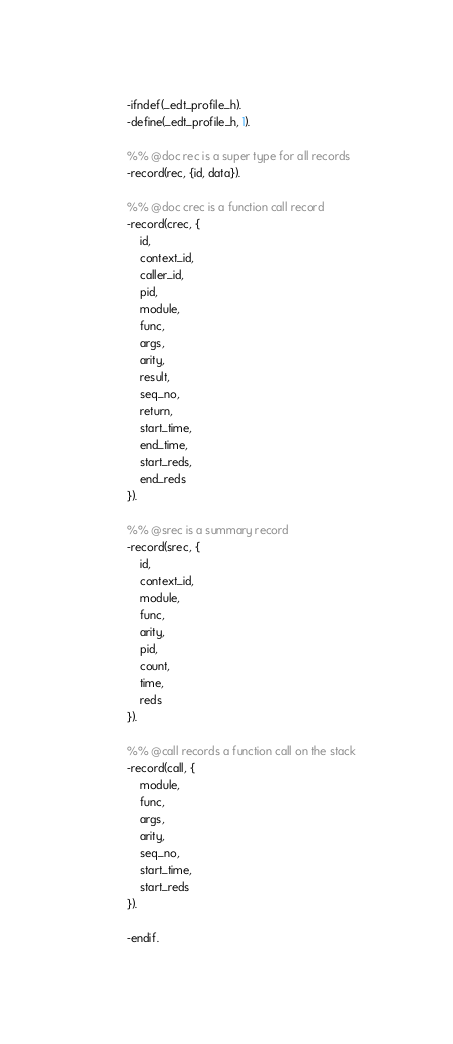<code> <loc_0><loc_0><loc_500><loc_500><_Erlang_>-ifndef(_edt_profile_h).
-define(_edt_profile_h, 1).

%% @doc rec is a super type for all records
-record(rec, {id, data}).

%% @doc crec is a function call record
-record(crec, {
    id,
    context_id,
    caller_id,
    pid,
    module,
    func,
    args,
    arity,
    result,
    seq_no,
    return,
    start_time,
    end_time,
    start_reds,
    end_reds
}).

%% @srec is a summary record
-record(srec, {
    id,
    context_id,
    module,
    func,
    arity,
    pid,
    count,
    time,
    reds
}).

%% @call records a function call on the stack
-record(call, {
    module,
    func,
    args,
    arity,
    seq_no,
    start_time,
    start_reds
}).

-endif.
</code> 